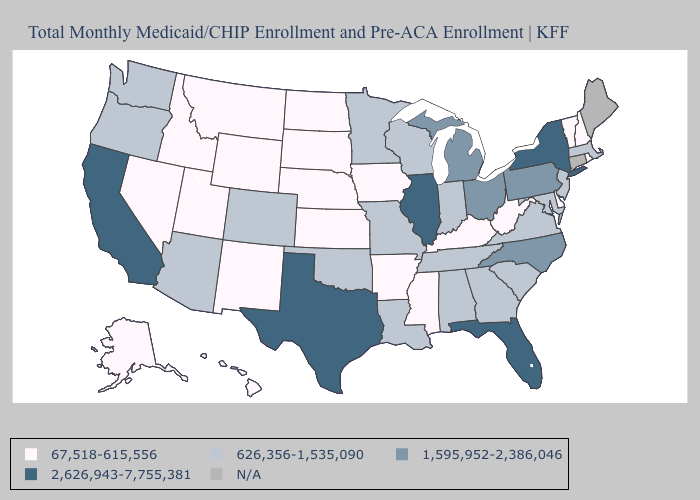What is the value of Illinois?
Give a very brief answer. 2,626,943-7,755,381. What is the highest value in states that border Rhode Island?
Quick response, please. 626,356-1,535,090. Name the states that have a value in the range N/A?
Give a very brief answer. Connecticut, Maine. What is the value of Nebraska?
Give a very brief answer. 67,518-615,556. Which states have the highest value in the USA?
Quick response, please. California, Florida, Illinois, New York, Texas. Name the states that have a value in the range 626,356-1,535,090?
Keep it brief. Alabama, Arizona, Colorado, Georgia, Indiana, Louisiana, Maryland, Massachusetts, Minnesota, Missouri, New Jersey, Oklahoma, Oregon, South Carolina, Tennessee, Virginia, Washington, Wisconsin. Is the legend a continuous bar?
Answer briefly. No. Which states have the highest value in the USA?
Write a very short answer. California, Florida, Illinois, New York, Texas. Is the legend a continuous bar?
Be succinct. No. What is the highest value in the USA?
Keep it brief. 2,626,943-7,755,381. What is the value of New Mexico?
Answer briefly. 67,518-615,556. What is the lowest value in states that border Maine?
Keep it brief. 67,518-615,556. How many symbols are there in the legend?
Be succinct. 5. Name the states that have a value in the range 1,595,952-2,386,046?
Quick response, please. Michigan, North Carolina, Ohio, Pennsylvania. 